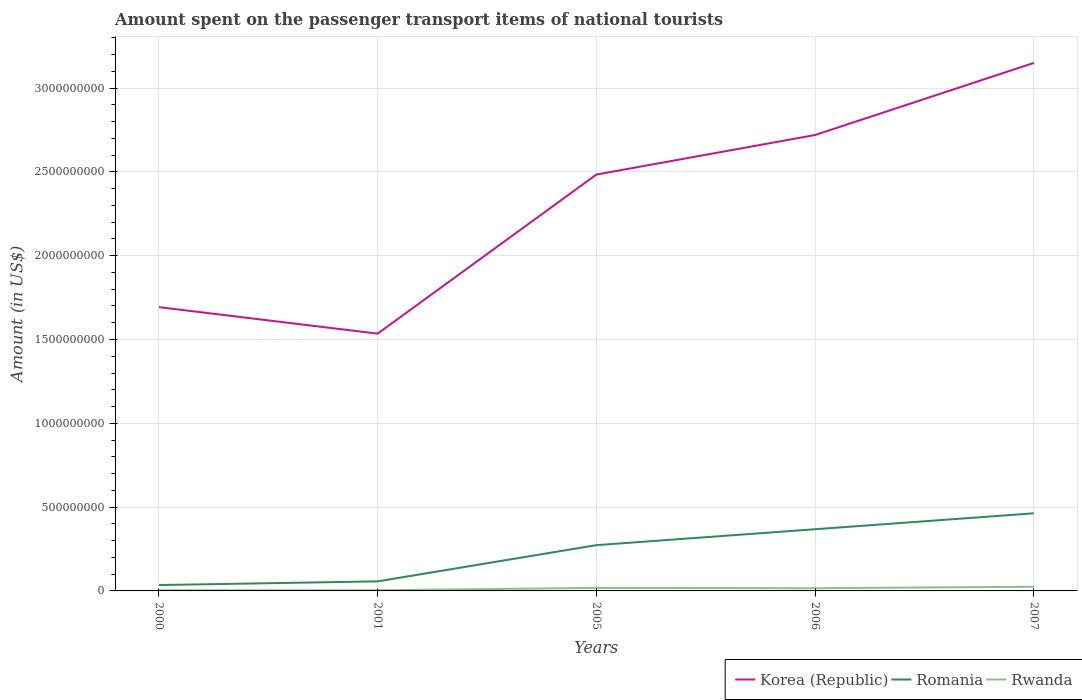How many different coloured lines are there?
Offer a very short reply. 3. Does the line corresponding to Korea (Republic) intersect with the line corresponding to Rwanda?
Ensure brevity in your answer.  No. Is the number of lines equal to the number of legend labels?
Offer a very short reply. Yes. Across all years, what is the maximum amount spent on the passenger transport items of national tourists in Romania?
Make the answer very short. 3.50e+07. In which year was the amount spent on the passenger transport items of national tourists in Rwanda maximum?
Offer a terse response. 2000. What is the total amount spent on the passenger transport items of national tourists in Romania in the graph?
Give a very brief answer. -9.50e+07. What is the difference between the highest and the second highest amount spent on the passenger transport items of national tourists in Korea (Republic)?
Your response must be concise. 1.62e+09. Is the amount spent on the passenger transport items of national tourists in Romania strictly greater than the amount spent on the passenger transport items of national tourists in Rwanda over the years?
Your answer should be very brief. No. How many years are there in the graph?
Your response must be concise. 5. What is the difference between two consecutive major ticks on the Y-axis?
Provide a short and direct response. 5.00e+08. How many legend labels are there?
Give a very brief answer. 3. How are the legend labels stacked?
Keep it short and to the point. Horizontal. What is the title of the graph?
Your answer should be compact. Amount spent on the passenger transport items of national tourists. What is the Amount (in US$) in Korea (Republic) in 2000?
Give a very brief answer. 1.69e+09. What is the Amount (in US$) in Romania in 2000?
Make the answer very short. 3.50e+07. What is the Amount (in US$) in Rwanda in 2000?
Your response must be concise. 4.00e+06. What is the Amount (in US$) in Korea (Republic) in 2001?
Provide a succinct answer. 1.54e+09. What is the Amount (in US$) of Romania in 2001?
Your response must be concise. 5.70e+07. What is the Amount (in US$) of Rwanda in 2001?
Your answer should be compact. 4.00e+06. What is the Amount (in US$) of Korea (Republic) in 2005?
Offer a very short reply. 2.48e+09. What is the Amount (in US$) of Romania in 2005?
Keep it short and to the point. 2.73e+08. What is the Amount (in US$) of Rwanda in 2005?
Your response must be concise. 1.80e+07. What is the Amount (in US$) of Korea (Republic) in 2006?
Ensure brevity in your answer.  2.72e+09. What is the Amount (in US$) of Romania in 2006?
Offer a very short reply. 3.68e+08. What is the Amount (in US$) in Rwanda in 2006?
Offer a terse response. 1.60e+07. What is the Amount (in US$) of Korea (Republic) in 2007?
Make the answer very short. 3.15e+09. What is the Amount (in US$) in Romania in 2007?
Provide a succinct answer. 4.63e+08. What is the Amount (in US$) in Rwanda in 2007?
Your answer should be very brief. 2.50e+07. Across all years, what is the maximum Amount (in US$) in Korea (Republic)?
Make the answer very short. 3.15e+09. Across all years, what is the maximum Amount (in US$) in Romania?
Ensure brevity in your answer.  4.63e+08. Across all years, what is the maximum Amount (in US$) in Rwanda?
Offer a very short reply. 2.50e+07. Across all years, what is the minimum Amount (in US$) in Korea (Republic)?
Give a very brief answer. 1.54e+09. Across all years, what is the minimum Amount (in US$) in Romania?
Your answer should be compact. 3.50e+07. What is the total Amount (in US$) of Korea (Republic) in the graph?
Your response must be concise. 1.16e+1. What is the total Amount (in US$) of Romania in the graph?
Provide a short and direct response. 1.20e+09. What is the total Amount (in US$) of Rwanda in the graph?
Keep it short and to the point. 6.70e+07. What is the difference between the Amount (in US$) in Korea (Republic) in 2000 and that in 2001?
Offer a terse response. 1.58e+08. What is the difference between the Amount (in US$) in Romania in 2000 and that in 2001?
Keep it short and to the point. -2.20e+07. What is the difference between the Amount (in US$) of Korea (Republic) in 2000 and that in 2005?
Provide a short and direct response. -7.91e+08. What is the difference between the Amount (in US$) in Romania in 2000 and that in 2005?
Offer a very short reply. -2.38e+08. What is the difference between the Amount (in US$) in Rwanda in 2000 and that in 2005?
Ensure brevity in your answer.  -1.40e+07. What is the difference between the Amount (in US$) of Korea (Republic) in 2000 and that in 2006?
Offer a very short reply. -1.03e+09. What is the difference between the Amount (in US$) in Romania in 2000 and that in 2006?
Provide a short and direct response. -3.33e+08. What is the difference between the Amount (in US$) in Rwanda in 2000 and that in 2006?
Your answer should be compact. -1.20e+07. What is the difference between the Amount (in US$) of Korea (Republic) in 2000 and that in 2007?
Make the answer very short. -1.46e+09. What is the difference between the Amount (in US$) in Romania in 2000 and that in 2007?
Make the answer very short. -4.28e+08. What is the difference between the Amount (in US$) of Rwanda in 2000 and that in 2007?
Your answer should be compact. -2.10e+07. What is the difference between the Amount (in US$) in Korea (Republic) in 2001 and that in 2005?
Give a very brief answer. -9.49e+08. What is the difference between the Amount (in US$) in Romania in 2001 and that in 2005?
Provide a short and direct response. -2.16e+08. What is the difference between the Amount (in US$) of Rwanda in 2001 and that in 2005?
Keep it short and to the point. -1.40e+07. What is the difference between the Amount (in US$) of Korea (Republic) in 2001 and that in 2006?
Ensure brevity in your answer.  -1.18e+09. What is the difference between the Amount (in US$) of Romania in 2001 and that in 2006?
Provide a succinct answer. -3.11e+08. What is the difference between the Amount (in US$) of Rwanda in 2001 and that in 2006?
Make the answer very short. -1.20e+07. What is the difference between the Amount (in US$) of Korea (Republic) in 2001 and that in 2007?
Offer a very short reply. -1.62e+09. What is the difference between the Amount (in US$) of Romania in 2001 and that in 2007?
Keep it short and to the point. -4.06e+08. What is the difference between the Amount (in US$) in Rwanda in 2001 and that in 2007?
Offer a terse response. -2.10e+07. What is the difference between the Amount (in US$) of Korea (Republic) in 2005 and that in 2006?
Give a very brief answer. -2.36e+08. What is the difference between the Amount (in US$) of Romania in 2005 and that in 2006?
Provide a succinct answer. -9.50e+07. What is the difference between the Amount (in US$) of Korea (Republic) in 2005 and that in 2007?
Make the answer very short. -6.66e+08. What is the difference between the Amount (in US$) of Romania in 2005 and that in 2007?
Provide a succinct answer. -1.90e+08. What is the difference between the Amount (in US$) in Rwanda in 2005 and that in 2007?
Make the answer very short. -7.00e+06. What is the difference between the Amount (in US$) of Korea (Republic) in 2006 and that in 2007?
Your answer should be compact. -4.30e+08. What is the difference between the Amount (in US$) of Romania in 2006 and that in 2007?
Your answer should be very brief. -9.50e+07. What is the difference between the Amount (in US$) of Rwanda in 2006 and that in 2007?
Keep it short and to the point. -9.00e+06. What is the difference between the Amount (in US$) in Korea (Republic) in 2000 and the Amount (in US$) in Romania in 2001?
Provide a short and direct response. 1.64e+09. What is the difference between the Amount (in US$) in Korea (Republic) in 2000 and the Amount (in US$) in Rwanda in 2001?
Offer a very short reply. 1.69e+09. What is the difference between the Amount (in US$) in Romania in 2000 and the Amount (in US$) in Rwanda in 2001?
Your response must be concise. 3.10e+07. What is the difference between the Amount (in US$) in Korea (Republic) in 2000 and the Amount (in US$) in Romania in 2005?
Offer a terse response. 1.42e+09. What is the difference between the Amount (in US$) of Korea (Republic) in 2000 and the Amount (in US$) of Rwanda in 2005?
Your response must be concise. 1.68e+09. What is the difference between the Amount (in US$) of Romania in 2000 and the Amount (in US$) of Rwanda in 2005?
Keep it short and to the point. 1.70e+07. What is the difference between the Amount (in US$) in Korea (Republic) in 2000 and the Amount (in US$) in Romania in 2006?
Keep it short and to the point. 1.32e+09. What is the difference between the Amount (in US$) in Korea (Republic) in 2000 and the Amount (in US$) in Rwanda in 2006?
Provide a succinct answer. 1.68e+09. What is the difference between the Amount (in US$) of Romania in 2000 and the Amount (in US$) of Rwanda in 2006?
Ensure brevity in your answer.  1.90e+07. What is the difference between the Amount (in US$) of Korea (Republic) in 2000 and the Amount (in US$) of Romania in 2007?
Keep it short and to the point. 1.23e+09. What is the difference between the Amount (in US$) in Korea (Republic) in 2000 and the Amount (in US$) in Rwanda in 2007?
Give a very brief answer. 1.67e+09. What is the difference between the Amount (in US$) of Romania in 2000 and the Amount (in US$) of Rwanda in 2007?
Ensure brevity in your answer.  1.00e+07. What is the difference between the Amount (in US$) of Korea (Republic) in 2001 and the Amount (in US$) of Romania in 2005?
Your answer should be compact. 1.26e+09. What is the difference between the Amount (in US$) of Korea (Republic) in 2001 and the Amount (in US$) of Rwanda in 2005?
Give a very brief answer. 1.52e+09. What is the difference between the Amount (in US$) in Romania in 2001 and the Amount (in US$) in Rwanda in 2005?
Ensure brevity in your answer.  3.90e+07. What is the difference between the Amount (in US$) of Korea (Republic) in 2001 and the Amount (in US$) of Romania in 2006?
Make the answer very short. 1.17e+09. What is the difference between the Amount (in US$) in Korea (Republic) in 2001 and the Amount (in US$) in Rwanda in 2006?
Ensure brevity in your answer.  1.52e+09. What is the difference between the Amount (in US$) of Romania in 2001 and the Amount (in US$) of Rwanda in 2006?
Make the answer very short. 4.10e+07. What is the difference between the Amount (in US$) in Korea (Republic) in 2001 and the Amount (in US$) in Romania in 2007?
Your answer should be very brief. 1.07e+09. What is the difference between the Amount (in US$) in Korea (Republic) in 2001 and the Amount (in US$) in Rwanda in 2007?
Ensure brevity in your answer.  1.51e+09. What is the difference between the Amount (in US$) of Romania in 2001 and the Amount (in US$) of Rwanda in 2007?
Make the answer very short. 3.20e+07. What is the difference between the Amount (in US$) of Korea (Republic) in 2005 and the Amount (in US$) of Romania in 2006?
Make the answer very short. 2.12e+09. What is the difference between the Amount (in US$) in Korea (Republic) in 2005 and the Amount (in US$) in Rwanda in 2006?
Ensure brevity in your answer.  2.47e+09. What is the difference between the Amount (in US$) of Romania in 2005 and the Amount (in US$) of Rwanda in 2006?
Keep it short and to the point. 2.57e+08. What is the difference between the Amount (in US$) of Korea (Republic) in 2005 and the Amount (in US$) of Romania in 2007?
Your answer should be compact. 2.02e+09. What is the difference between the Amount (in US$) of Korea (Republic) in 2005 and the Amount (in US$) of Rwanda in 2007?
Provide a succinct answer. 2.46e+09. What is the difference between the Amount (in US$) in Romania in 2005 and the Amount (in US$) in Rwanda in 2007?
Give a very brief answer. 2.48e+08. What is the difference between the Amount (in US$) of Korea (Republic) in 2006 and the Amount (in US$) of Romania in 2007?
Keep it short and to the point. 2.26e+09. What is the difference between the Amount (in US$) of Korea (Republic) in 2006 and the Amount (in US$) of Rwanda in 2007?
Your answer should be very brief. 2.70e+09. What is the difference between the Amount (in US$) in Romania in 2006 and the Amount (in US$) in Rwanda in 2007?
Your answer should be compact. 3.43e+08. What is the average Amount (in US$) in Korea (Republic) per year?
Keep it short and to the point. 2.32e+09. What is the average Amount (in US$) in Romania per year?
Your answer should be very brief. 2.39e+08. What is the average Amount (in US$) in Rwanda per year?
Your answer should be very brief. 1.34e+07. In the year 2000, what is the difference between the Amount (in US$) of Korea (Republic) and Amount (in US$) of Romania?
Offer a terse response. 1.66e+09. In the year 2000, what is the difference between the Amount (in US$) in Korea (Republic) and Amount (in US$) in Rwanda?
Offer a terse response. 1.69e+09. In the year 2000, what is the difference between the Amount (in US$) in Romania and Amount (in US$) in Rwanda?
Keep it short and to the point. 3.10e+07. In the year 2001, what is the difference between the Amount (in US$) of Korea (Republic) and Amount (in US$) of Romania?
Offer a terse response. 1.48e+09. In the year 2001, what is the difference between the Amount (in US$) in Korea (Republic) and Amount (in US$) in Rwanda?
Offer a terse response. 1.53e+09. In the year 2001, what is the difference between the Amount (in US$) in Romania and Amount (in US$) in Rwanda?
Provide a succinct answer. 5.30e+07. In the year 2005, what is the difference between the Amount (in US$) of Korea (Republic) and Amount (in US$) of Romania?
Keep it short and to the point. 2.21e+09. In the year 2005, what is the difference between the Amount (in US$) of Korea (Republic) and Amount (in US$) of Rwanda?
Keep it short and to the point. 2.47e+09. In the year 2005, what is the difference between the Amount (in US$) of Romania and Amount (in US$) of Rwanda?
Give a very brief answer. 2.55e+08. In the year 2006, what is the difference between the Amount (in US$) of Korea (Republic) and Amount (in US$) of Romania?
Keep it short and to the point. 2.35e+09. In the year 2006, what is the difference between the Amount (in US$) in Korea (Republic) and Amount (in US$) in Rwanda?
Keep it short and to the point. 2.70e+09. In the year 2006, what is the difference between the Amount (in US$) in Romania and Amount (in US$) in Rwanda?
Make the answer very short. 3.52e+08. In the year 2007, what is the difference between the Amount (in US$) in Korea (Republic) and Amount (in US$) in Romania?
Keep it short and to the point. 2.69e+09. In the year 2007, what is the difference between the Amount (in US$) of Korea (Republic) and Amount (in US$) of Rwanda?
Offer a terse response. 3.12e+09. In the year 2007, what is the difference between the Amount (in US$) in Romania and Amount (in US$) in Rwanda?
Provide a short and direct response. 4.38e+08. What is the ratio of the Amount (in US$) of Korea (Republic) in 2000 to that in 2001?
Your answer should be very brief. 1.1. What is the ratio of the Amount (in US$) of Romania in 2000 to that in 2001?
Provide a succinct answer. 0.61. What is the ratio of the Amount (in US$) in Rwanda in 2000 to that in 2001?
Provide a short and direct response. 1. What is the ratio of the Amount (in US$) of Korea (Republic) in 2000 to that in 2005?
Make the answer very short. 0.68. What is the ratio of the Amount (in US$) of Romania in 2000 to that in 2005?
Your answer should be very brief. 0.13. What is the ratio of the Amount (in US$) in Rwanda in 2000 to that in 2005?
Offer a very short reply. 0.22. What is the ratio of the Amount (in US$) in Korea (Republic) in 2000 to that in 2006?
Your response must be concise. 0.62. What is the ratio of the Amount (in US$) of Romania in 2000 to that in 2006?
Your response must be concise. 0.1. What is the ratio of the Amount (in US$) in Rwanda in 2000 to that in 2006?
Give a very brief answer. 0.25. What is the ratio of the Amount (in US$) of Korea (Republic) in 2000 to that in 2007?
Provide a succinct answer. 0.54. What is the ratio of the Amount (in US$) of Romania in 2000 to that in 2007?
Provide a succinct answer. 0.08. What is the ratio of the Amount (in US$) of Rwanda in 2000 to that in 2007?
Provide a short and direct response. 0.16. What is the ratio of the Amount (in US$) in Korea (Republic) in 2001 to that in 2005?
Provide a short and direct response. 0.62. What is the ratio of the Amount (in US$) in Romania in 2001 to that in 2005?
Your answer should be compact. 0.21. What is the ratio of the Amount (in US$) in Rwanda in 2001 to that in 2005?
Your answer should be compact. 0.22. What is the ratio of the Amount (in US$) in Korea (Republic) in 2001 to that in 2006?
Offer a terse response. 0.56. What is the ratio of the Amount (in US$) in Romania in 2001 to that in 2006?
Offer a very short reply. 0.15. What is the ratio of the Amount (in US$) in Korea (Republic) in 2001 to that in 2007?
Ensure brevity in your answer.  0.49. What is the ratio of the Amount (in US$) of Romania in 2001 to that in 2007?
Your answer should be compact. 0.12. What is the ratio of the Amount (in US$) in Rwanda in 2001 to that in 2007?
Keep it short and to the point. 0.16. What is the ratio of the Amount (in US$) of Korea (Republic) in 2005 to that in 2006?
Ensure brevity in your answer.  0.91. What is the ratio of the Amount (in US$) in Romania in 2005 to that in 2006?
Ensure brevity in your answer.  0.74. What is the ratio of the Amount (in US$) in Korea (Republic) in 2005 to that in 2007?
Provide a short and direct response. 0.79. What is the ratio of the Amount (in US$) in Romania in 2005 to that in 2007?
Your answer should be very brief. 0.59. What is the ratio of the Amount (in US$) of Rwanda in 2005 to that in 2007?
Make the answer very short. 0.72. What is the ratio of the Amount (in US$) in Korea (Republic) in 2006 to that in 2007?
Provide a succinct answer. 0.86. What is the ratio of the Amount (in US$) of Romania in 2006 to that in 2007?
Offer a very short reply. 0.79. What is the ratio of the Amount (in US$) of Rwanda in 2006 to that in 2007?
Provide a short and direct response. 0.64. What is the difference between the highest and the second highest Amount (in US$) of Korea (Republic)?
Ensure brevity in your answer.  4.30e+08. What is the difference between the highest and the second highest Amount (in US$) of Romania?
Provide a succinct answer. 9.50e+07. What is the difference between the highest and the second highest Amount (in US$) in Rwanda?
Provide a succinct answer. 7.00e+06. What is the difference between the highest and the lowest Amount (in US$) of Korea (Republic)?
Provide a succinct answer. 1.62e+09. What is the difference between the highest and the lowest Amount (in US$) in Romania?
Your response must be concise. 4.28e+08. What is the difference between the highest and the lowest Amount (in US$) in Rwanda?
Ensure brevity in your answer.  2.10e+07. 